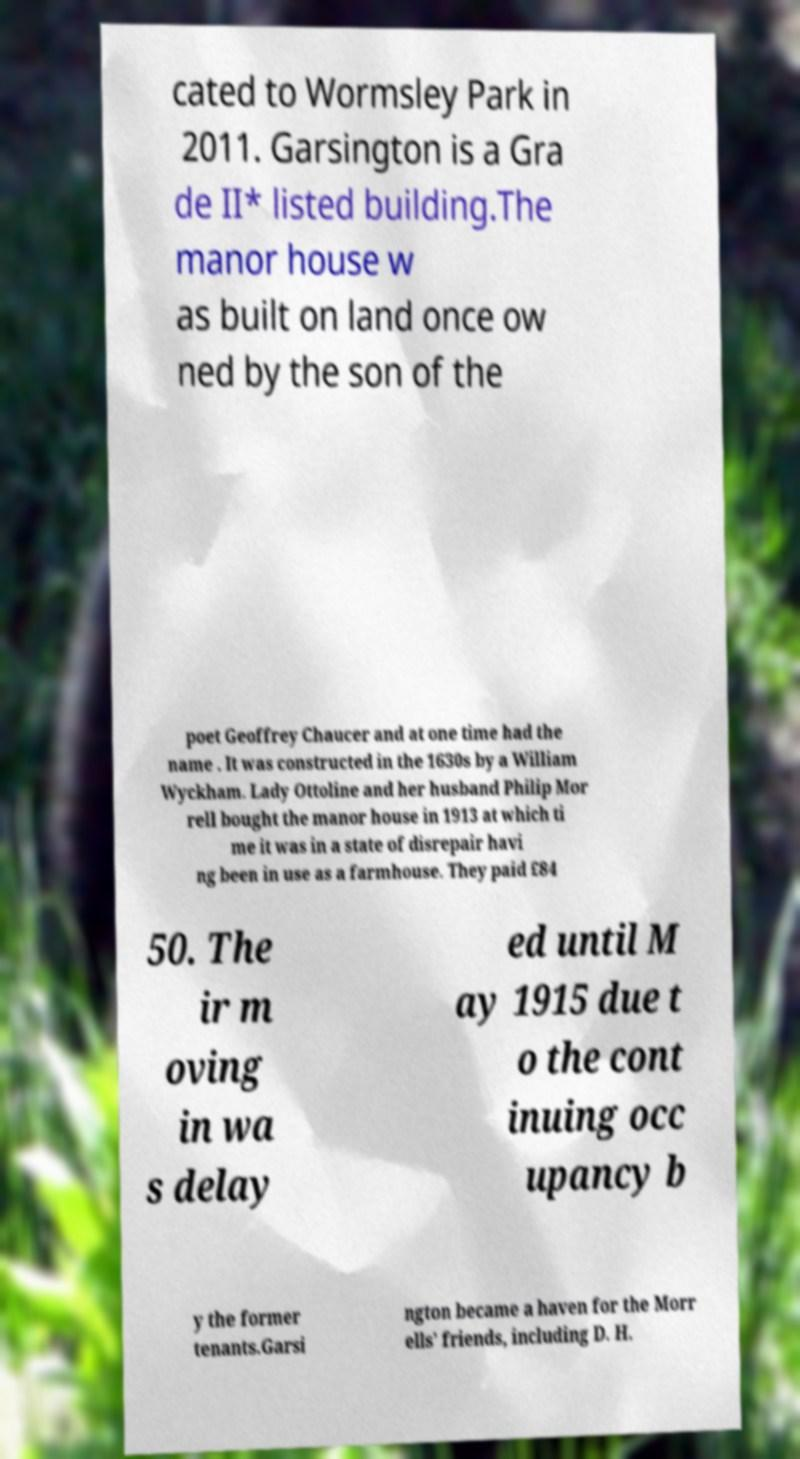Please read and relay the text visible in this image. What does it say? cated to Wormsley Park in 2011. Garsington is a Gra de II* listed building.The manor house w as built on land once ow ned by the son of the poet Geoffrey Chaucer and at one time had the name . It was constructed in the 1630s by a William Wyckham. Lady Ottoline and her husband Philip Mor rell bought the manor house in 1913 at which ti me it was in a state of disrepair havi ng been in use as a farmhouse. They paid £84 50. The ir m oving in wa s delay ed until M ay 1915 due t o the cont inuing occ upancy b y the former tenants.Garsi ngton became a haven for the Morr ells’ friends, including D. H. 